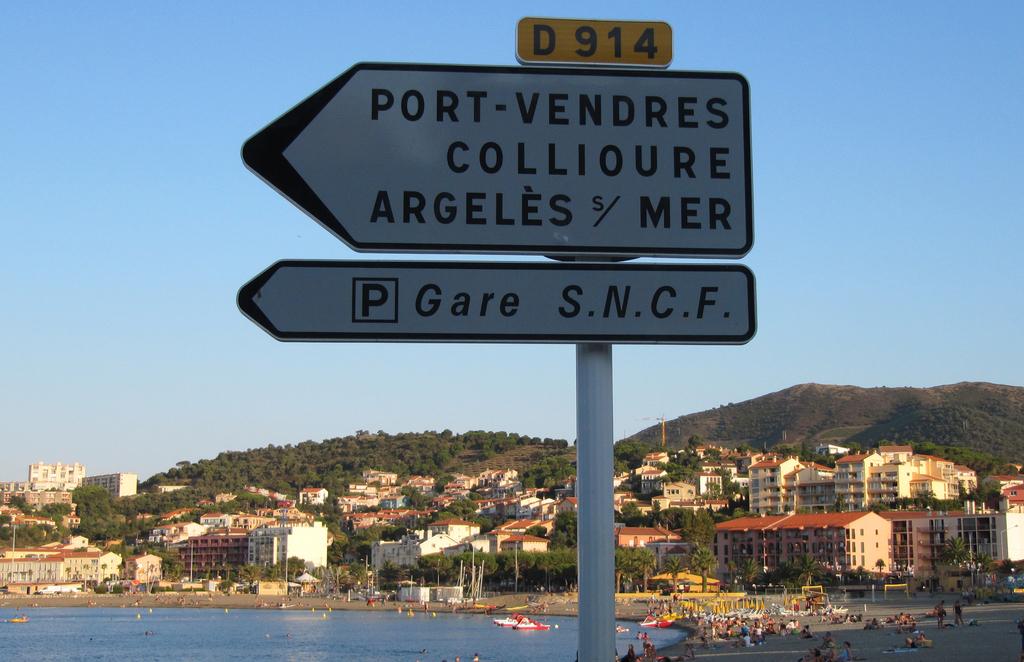What port is the sign pointing to?
Give a very brief answer. Vendres. 